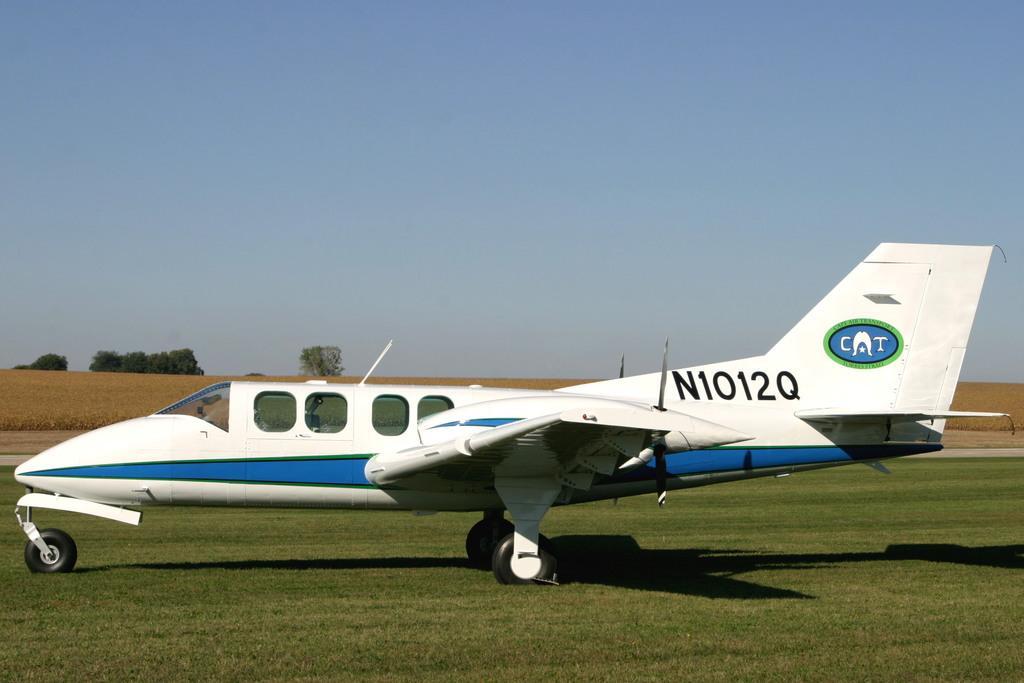Can you describe this image briefly? In this picture I can see an airplane on the ground. In the background, I can see trees and the sky. Here I can see the grass and shadows on the ground. 